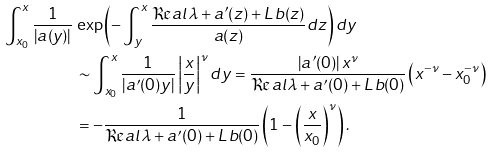<formula> <loc_0><loc_0><loc_500><loc_500>\int _ { x _ { 0 } } ^ { x } \frac { 1 } { | a ( y ) | } \, & \exp \left ( - \int _ { y } ^ { x } \frac { \Re a l \lambda + a ^ { \prime } ( z ) + L \, b ( z ) } { a ( z ) } d z \right ) d y \\ & \sim \int _ { x _ { 0 } } ^ { x } \frac { 1 } { | a ^ { \prime } ( 0 ) y | } \left | \frac { x } { y } \right | ^ { \nu } d y = \frac { | a ^ { \prime } ( 0 ) | \, x ^ { \nu } } { \Re a l \lambda + a ^ { \prime } ( 0 ) + L \, b ( 0 ) } \left ( x ^ { - \nu } - x _ { 0 } ^ { - \nu } \right ) \\ & = - \frac { 1 } { \Re a l \lambda + a ^ { \prime } ( 0 ) + L \, b ( 0 ) } \left ( 1 - \left ( \frac { x } { x _ { 0 } } \right ) ^ { \nu } \right ) .</formula> 